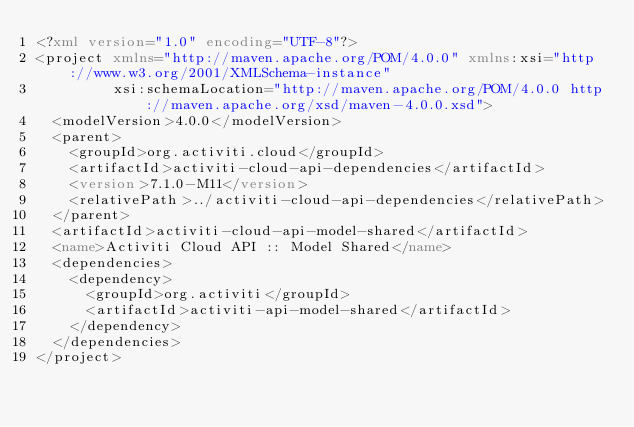<code> <loc_0><loc_0><loc_500><loc_500><_XML_><?xml version="1.0" encoding="UTF-8"?>
<project xmlns="http://maven.apache.org/POM/4.0.0" xmlns:xsi="http://www.w3.org/2001/XMLSchema-instance"
         xsi:schemaLocation="http://maven.apache.org/POM/4.0.0 http://maven.apache.org/xsd/maven-4.0.0.xsd">
  <modelVersion>4.0.0</modelVersion>
  <parent>
    <groupId>org.activiti.cloud</groupId>
    <artifactId>activiti-cloud-api-dependencies</artifactId>
    <version>7.1.0-M11</version>
    <relativePath>../activiti-cloud-api-dependencies</relativePath>
  </parent>
  <artifactId>activiti-cloud-api-model-shared</artifactId>
  <name>Activiti Cloud API :: Model Shared</name>
  <dependencies>
    <dependency>
      <groupId>org.activiti</groupId>
      <artifactId>activiti-api-model-shared</artifactId>
    </dependency>
  </dependencies>
</project>
</code> 